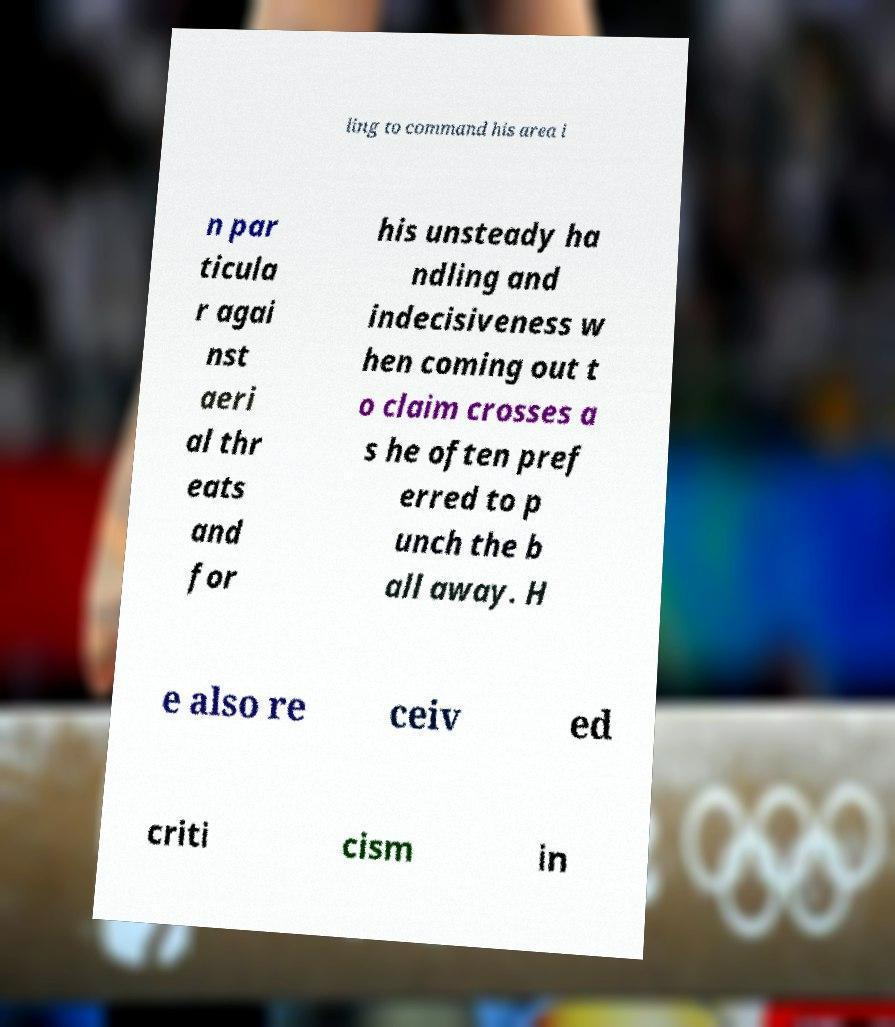There's text embedded in this image that I need extracted. Can you transcribe it verbatim? ling to command his area i n par ticula r agai nst aeri al thr eats and for his unsteady ha ndling and indecisiveness w hen coming out t o claim crosses a s he often pref erred to p unch the b all away. H e also re ceiv ed criti cism in 